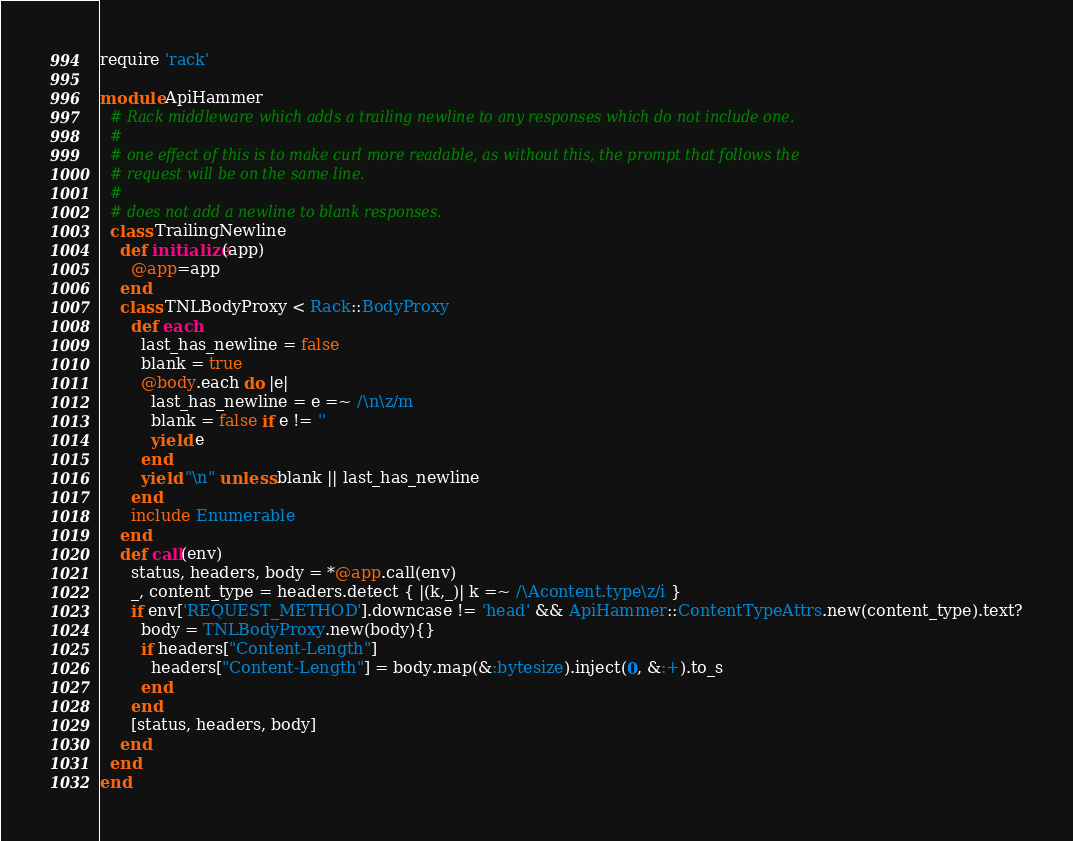Convert code to text. <code><loc_0><loc_0><loc_500><loc_500><_Ruby_>require 'rack'

module ApiHammer
  # Rack middleware which adds a trailing newline to any responses which do not include one. 
  #
  # one effect of this is to make curl more readable, as without this, the prompt that follows the 
  # request will be on the same line. 
  #
  # does not add a newline to blank responses.
  class TrailingNewline
    def initialize(app)
      @app=app
    end
    class TNLBodyProxy < Rack::BodyProxy
      def each
        last_has_newline = false
        blank = true
        @body.each do |e|
          last_has_newline = e =~ /\n\z/m
          blank = false if e != ''
          yield e
        end
        yield "\n" unless blank || last_has_newline
      end
      include Enumerable
    end
    def call(env)
      status, headers, body = *@app.call(env)
      _, content_type = headers.detect { |(k,_)| k =~ /\Acontent.type\z/i }
      if env['REQUEST_METHOD'].downcase != 'head' && ApiHammer::ContentTypeAttrs.new(content_type).text?
        body = TNLBodyProxy.new(body){}
        if headers["Content-Length"]
          headers["Content-Length"] = body.map(&:bytesize).inject(0, &:+).to_s
        end
      end
      [status, headers, body]
    end
  end
end
</code> 